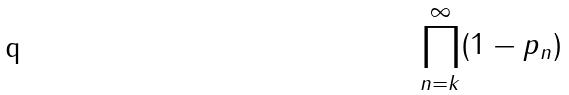<formula> <loc_0><loc_0><loc_500><loc_500>\prod _ { n = k } ^ { \infty } ( 1 - p _ { n } )</formula> 